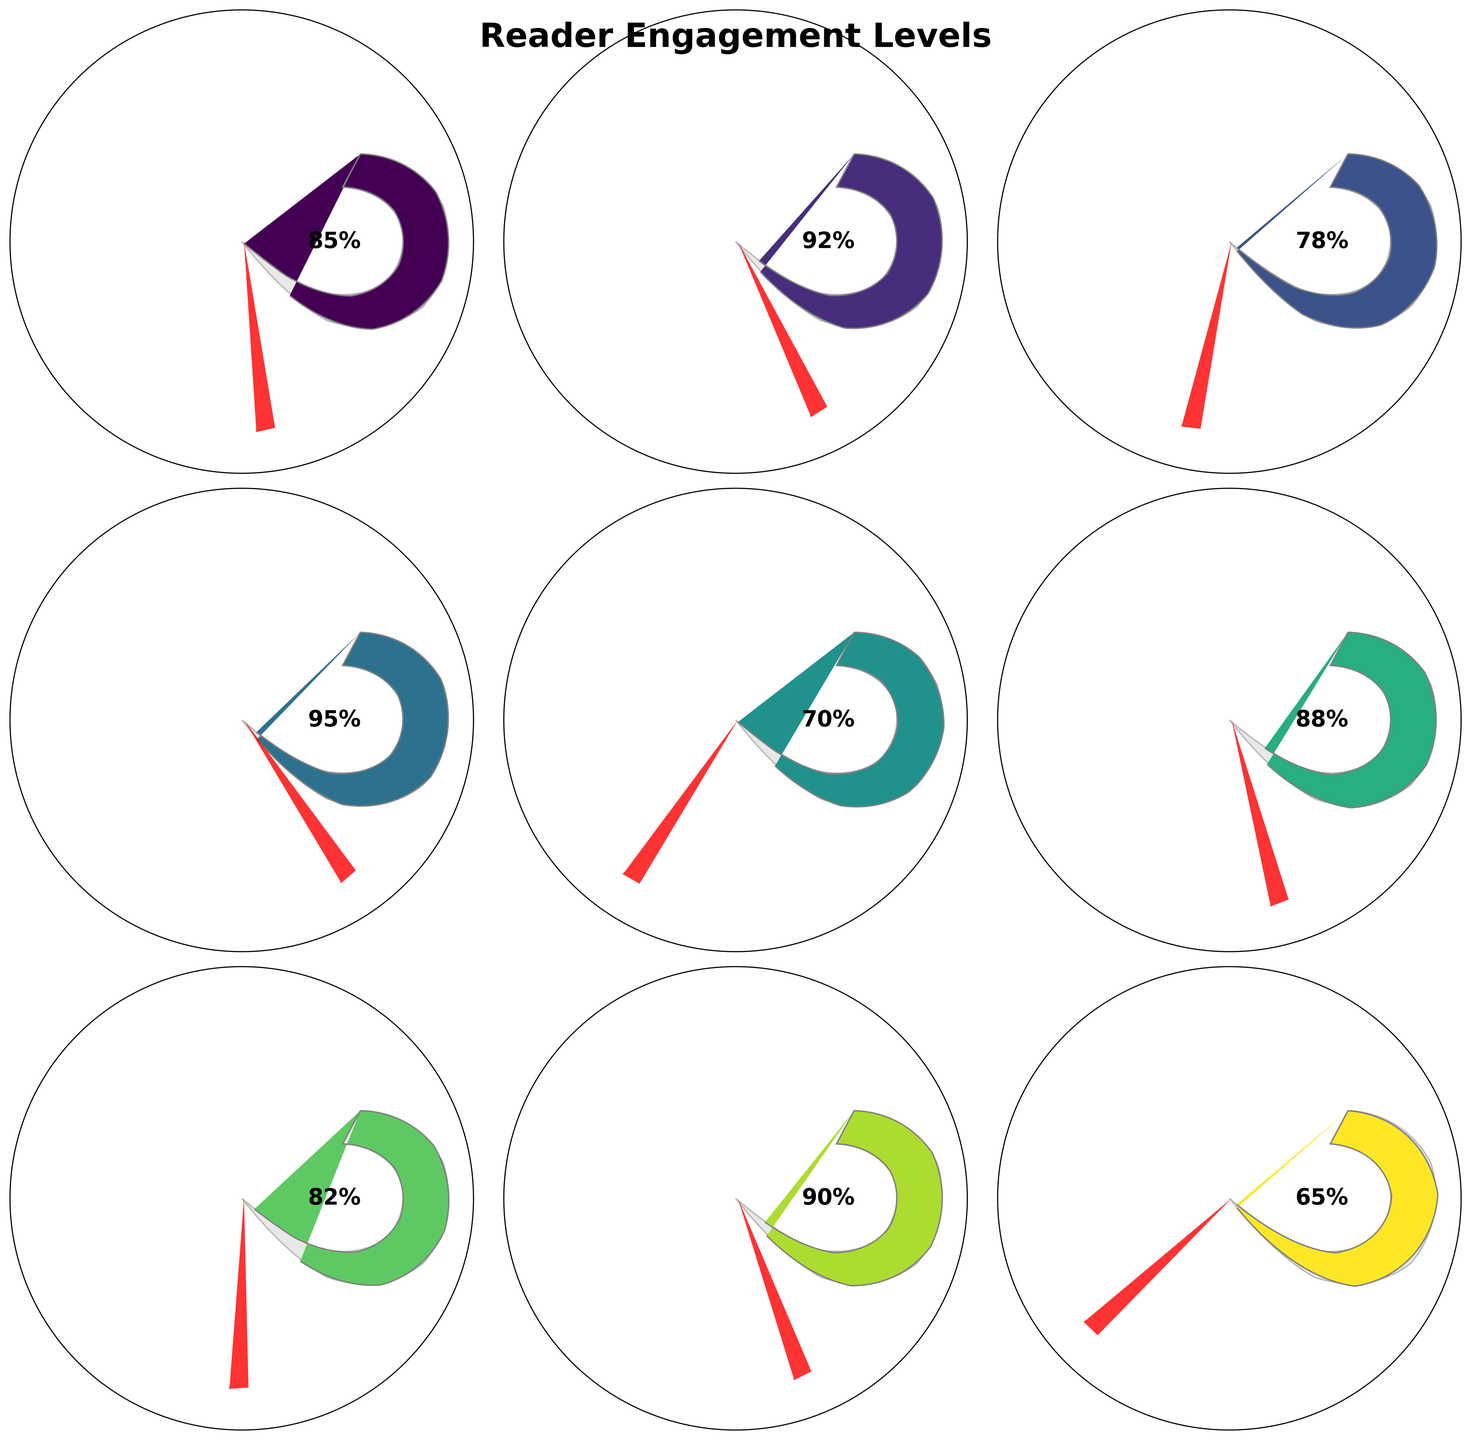Which story arc has the highest reader engagement level? By looking at the values labeled at the center of each gauge, we can determine the highest engagement level. "Epic Battle" shows 95%, which is the highest among all listed arcs.
Answer: Epic Battle What is the title of the figure? The title is displayed at the top of the figure in a bold font, labeled "Reader Engagement Levels."
Answer: Reader Engagement Levels What is the average engagement level across all story arcs? First, sum all engagement levels (85 + 92 + 78 + 95 + 70 + 88 + 82 + 90 + 65 = 745). Then divide by the number of story arcs (9): 745/9 ≈ 82.78
Answer: 82.78 Which story arc has the lowest reader engagement level? By identifying the smallest percentage number displayed within the gauges, we see that "Epilogue" has the lowest engagement level at 65%.
Answer: Epilogue How many story arcs have an engagement level above 80%? Count the number of story arcs with labels indicating an engagement level greater than 80%. These are "Origin Story," "Rise of the Villain," "Epic Battle," "Plot Twist," "Crossover Event," and "Redemption Arc," totaling six arcs.
Answer: 6 Which story arc has a higher engagement level, "Origin Story" or "Character Development"? Compare the engagement levels for these arcs: "Origin Story" is at 85%, while "Character Development" is at 70%. Therefore, "Origin Story" has a higher engagement level.
Answer: Origin Story How much higher is the engagement level of "Rise of the Villain" compared to "Hero's Journey"? Subtract the engagement level of "Hero's Journey" from "Rise of the Villain" (92 - 78 = 14).
Answer: 14 Which arc shows an engagement level closest to the average engagement level? The average engagement level calculated is approximately 82.78%. Among "Origin Story" (85), "Rise of the Villain" (92), "Hero's Journey" (78), "Epic Battle" (95), "Character Development" (70), "Plot Twist" (88), "Redemption Arc" (82), "Crossover Event" (90), and "Epilogue" (65), "Redemption Arc" at 82% is the closest.
Answer: Redemption Arc What can you conclude about the general trend in reader engagement levels across different story arcs? By examining the engagement levels of all arcs, we notice relatively high engagement for action-packed or critical plot points like "Rise of the Villain," "Epic Battle," and "Crossover Event," whereas transitional or concluding arcs like "Character Development" and "Epilogue" show lower engagement. This indicates readers are more engaged with intense and pivotal moments.
Answer: Readers are more engaged with intense and pivotal moments 